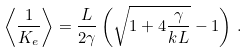Convert formula to latex. <formula><loc_0><loc_0><loc_500><loc_500>\left < \frac { 1 } { K _ { e } } \right > = \frac { L } { 2 \gamma } \left ( \sqrt { 1 + 4 \frac { \gamma } { k L } } - 1 \right ) \, .</formula> 